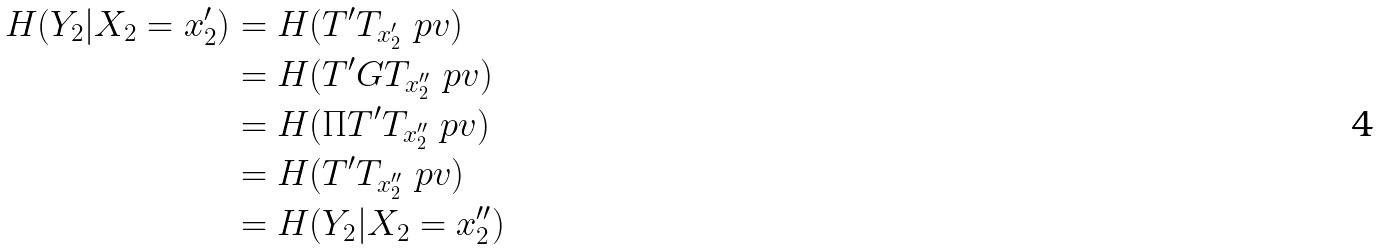Convert formula to latex. <formula><loc_0><loc_0><loc_500><loc_500>H ( Y _ { 2 } | X _ { 2 } = x _ { 2 } ^ { \prime } ) & = H ( T ^ { \prime } T _ { x _ { 2 } ^ { \prime } } \ p v ) \\ & = H ( T ^ { \prime } G T _ { x _ { 2 } ^ { \prime \prime } } \ p v ) \\ & = H ( \Pi T ^ { \prime } T _ { x _ { 2 } ^ { \prime \prime } } \ p v ) \\ & = H ( T ^ { \prime } T _ { x _ { 2 } ^ { \prime \prime } } \ p v ) \\ & = H ( Y _ { 2 } | X _ { 2 } = x _ { 2 } ^ { \prime \prime } )</formula> 